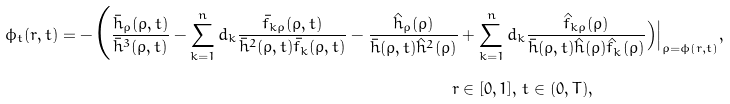<formula> <loc_0><loc_0><loc_500><loc_500>\phi _ { t } ( r , t ) = - \Big ( \frac { \bar { h } _ { \rho } ( \rho , t ) } { \bar { h } ^ { 3 } ( \rho , t ) } - \sum _ { k = 1 } ^ { n } d _ { k } \frac { \bar { f } _ { k \rho } ( \rho , t ) } { \bar { h } ^ { 2 } ( \rho , t ) \bar { f } _ { k } ( \rho , t ) } - \frac { \hat { h } _ { \rho } ( \rho ) } { \bar { h } ( \rho , t ) \hat { h } ^ { 2 } ( \rho ) } & + \sum _ { k = 1 } ^ { n } d _ { k } \frac { \hat { f } _ { k \rho } ( \rho ) } { \bar { h } ( \rho , t ) \hat { h } ( \rho ) \hat { f } _ { k } ( \rho ) } \Big ) \Big | _ { \rho = \phi ( r , t ) } , \\ r & \in [ 0 , 1 ] , \, t \in ( 0 , T ) ,</formula> 